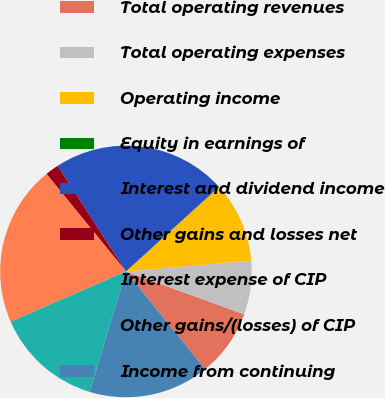Convert chart. <chart><loc_0><loc_0><loc_500><loc_500><pie_chart><fcel>Total operating revenues<fcel>Total operating expenses<fcel>Operating income<fcel>Equity in earnings of<fcel>Interest and dividend income<fcel>Other gains and losses net<fcel>Interest expense of CIP<fcel>Other gains/(losses) of CIP<fcel>Income from continuing<nl><fcel>8.63%<fcel>6.91%<fcel>10.35%<fcel>0.03%<fcel>22.38%<fcel>1.75%<fcel>20.66%<fcel>13.79%<fcel>15.5%<nl></chart> 